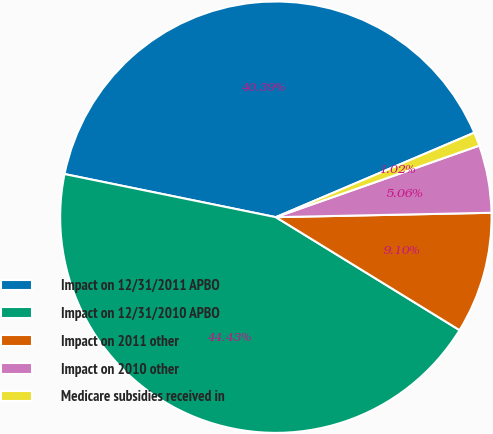Convert chart. <chart><loc_0><loc_0><loc_500><loc_500><pie_chart><fcel>Impact on 12/31/2011 APBO<fcel>Impact on 12/31/2010 APBO<fcel>Impact on 2011 other<fcel>Impact on 2010 other<fcel>Medicare subsidies received in<nl><fcel>40.39%<fcel>44.43%<fcel>9.1%<fcel>5.06%<fcel>1.02%<nl></chart> 